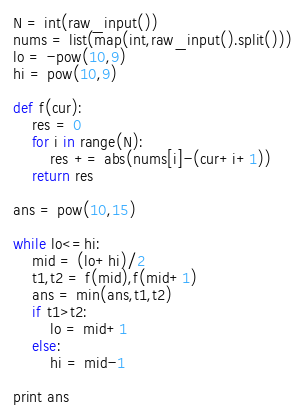Convert code to text. <code><loc_0><loc_0><loc_500><loc_500><_Python_>N = int(raw_input())
nums = list(map(int,raw_input().split()))
lo = -pow(10,9)
hi = pow(10,9)

def f(cur):
    res = 0
    for i in range(N):
        res += abs(nums[i]-(cur+i+1))
    return res

ans = pow(10,15)

while lo<=hi:
    mid = (lo+hi)/2
    t1,t2 = f(mid),f(mid+1)
    ans = min(ans,t1,t2)
    if t1>t2:
        lo = mid+1
    else:
        hi = mid-1

print ans</code> 